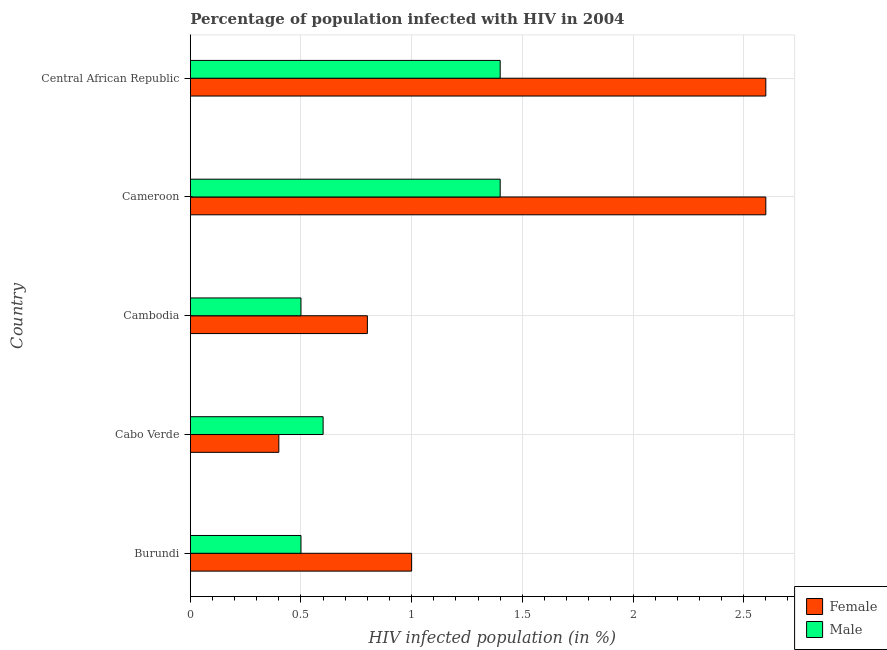Are the number of bars per tick equal to the number of legend labels?
Make the answer very short. Yes. Are the number of bars on each tick of the Y-axis equal?
Give a very brief answer. Yes. How many bars are there on the 2nd tick from the top?
Your response must be concise. 2. How many bars are there on the 4th tick from the bottom?
Make the answer very short. 2. What is the label of the 2nd group of bars from the top?
Ensure brevity in your answer.  Cameroon. In how many cases, is the number of bars for a given country not equal to the number of legend labels?
Provide a succinct answer. 0. Across all countries, what is the minimum percentage of females who are infected with hiv?
Make the answer very short. 0.4. In which country was the percentage of males who are infected with hiv maximum?
Make the answer very short. Cameroon. In which country was the percentage of males who are infected with hiv minimum?
Offer a very short reply. Burundi. What is the difference between the percentage of females who are infected with hiv in Cambodia and the percentage of males who are infected with hiv in Cabo Verde?
Your answer should be compact. 0.2. What is the average percentage of females who are infected with hiv per country?
Give a very brief answer. 1.48. In how many countries, is the percentage of females who are infected with hiv greater than 0.2 %?
Your response must be concise. 5. Is the percentage of females who are infected with hiv in Cabo Verde less than that in Cameroon?
Your answer should be compact. Yes. What does the 2nd bar from the top in Cambodia represents?
Provide a short and direct response. Female. What does the 2nd bar from the bottom in Central African Republic represents?
Give a very brief answer. Male. How many bars are there?
Ensure brevity in your answer.  10. How many countries are there in the graph?
Offer a terse response. 5. What is the difference between two consecutive major ticks on the X-axis?
Ensure brevity in your answer.  0.5. How many legend labels are there?
Make the answer very short. 2. How are the legend labels stacked?
Your answer should be very brief. Vertical. What is the title of the graph?
Your answer should be compact. Percentage of population infected with HIV in 2004. Does "Drinking water services" appear as one of the legend labels in the graph?
Give a very brief answer. No. What is the label or title of the X-axis?
Offer a terse response. HIV infected population (in %). What is the HIV infected population (in %) in Male in Burundi?
Keep it short and to the point. 0.5. What is the HIV infected population (in %) of Female in Cabo Verde?
Your answer should be compact. 0.4. What is the HIV infected population (in %) of Male in Cabo Verde?
Provide a short and direct response. 0.6. What is the HIV infected population (in %) in Male in Cambodia?
Provide a short and direct response. 0.5. What is the HIV infected population (in %) of Female in Central African Republic?
Provide a succinct answer. 2.6. What is the HIV infected population (in %) in Male in Central African Republic?
Offer a terse response. 1.4. Across all countries, what is the maximum HIV infected population (in %) of Male?
Make the answer very short. 1.4. Across all countries, what is the minimum HIV infected population (in %) of Female?
Your response must be concise. 0.4. Across all countries, what is the minimum HIV infected population (in %) of Male?
Provide a succinct answer. 0.5. What is the total HIV infected population (in %) of Female in the graph?
Offer a terse response. 7.4. What is the total HIV infected population (in %) in Male in the graph?
Offer a terse response. 4.4. What is the difference between the HIV infected population (in %) of Female in Burundi and that in Cabo Verde?
Your answer should be compact. 0.6. What is the difference between the HIV infected population (in %) of Male in Burundi and that in Cambodia?
Provide a short and direct response. 0. What is the difference between the HIV infected population (in %) in Male in Burundi and that in Cameroon?
Provide a short and direct response. -0.9. What is the difference between the HIV infected population (in %) in Male in Burundi and that in Central African Republic?
Offer a terse response. -0.9. What is the difference between the HIV infected population (in %) in Male in Cabo Verde and that in Central African Republic?
Your response must be concise. -0.8. What is the difference between the HIV infected population (in %) in Male in Cambodia and that in Central African Republic?
Provide a short and direct response. -0.9. What is the difference between the HIV infected population (in %) in Male in Cameroon and that in Central African Republic?
Your response must be concise. 0. What is the difference between the HIV infected population (in %) in Female in Burundi and the HIV infected population (in %) in Male in Cameroon?
Your answer should be compact. -0.4. What is the difference between the HIV infected population (in %) in Female in Burundi and the HIV infected population (in %) in Male in Central African Republic?
Make the answer very short. -0.4. What is the difference between the HIV infected population (in %) in Female in Cabo Verde and the HIV infected population (in %) in Male in Central African Republic?
Make the answer very short. -1. What is the difference between the HIV infected population (in %) of Female in Cambodia and the HIV infected population (in %) of Male in Central African Republic?
Provide a succinct answer. -0.6. What is the average HIV infected population (in %) of Female per country?
Give a very brief answer. 1.48. What is the ratio of the HIV infected population (in %) in Female in Burundi to that in Cabo Verde?
Give a very brief answer. 2.5. What is the ratio of the HIV infected population (in %) of Female in Burundi to that in Cambodia?
Your answer should be very brief. 1.25. What is the ratio of the HIV infected population (in %) in Female in Burundi to that in Cameroon?
Offer a terse response. 0.38. What is the ratio of the HIV infected population (in %) of Male in Burundi to that in Cameroon?
Your answer should be very brief. 0.36. What is the ratio of the HIV infected population (in %) of Female in Burundi to that in Central African Republic?
Offer a very short reply. 0.38. What is the ratio of the HIV infected population (in %) in Male in Burundi to that in Central African Republic?
Provide a succinct answer. 0.36. What is the ratio of the HIV infected population (in %) in Female in Cabo Verde to that in Cambodia?
Your answer should be compact. 0.5. What is the ratio of the HIV infected population (in %) in Male in Cabo Verde to that in Cambodia?
Your response must be concise. 1.2. What is the ratio of the HIV infected population (in %) of Female in Cabo Verde to that in Cameroon?
Provide a short and direct response. 0.15. What is the ratio of the HIV infected population (in %) in Male in Cabo Verde to that in Cameroon?
Keep it short and to the point. 0.43. What is the ratio of the HIV infected population (in %) in Female in Cabo Verde to that in Central African Republic?
Offer a terse response. 0.15. What is the ratio of the HIV infected population (in %) in Male in Cabo Verde to that in Central African Republic?
Your response must be concise. 0.43. What is the ratio of the HIV infected population (in %) in Female in Cambodia to that in Cameroon?
Offer a very short reply. 0.31. What is the ratio of the HIV infected population (in %) in Male in Cambodia to that in Cameroon?
Keep it short and to the point. 0.36. What is the ratio of the HIV infected population (in %) of Female in Cambodia to that in Central African Republic?
Offer a very short reply. 0.31. What is the ratio of the HIV infected population (in %) in Male in Cambodia to that in Central African Republic?
Provide a succinct answer. 0.36. What is the ratio of the HIV infected population (in %) of Male in Cameroon to that in Central African Republic?
Make the answer very short. 1. What is the difference between the highest and the lowest HIV infected population (in %) of Female?
Offer a terse response. 2.2. 